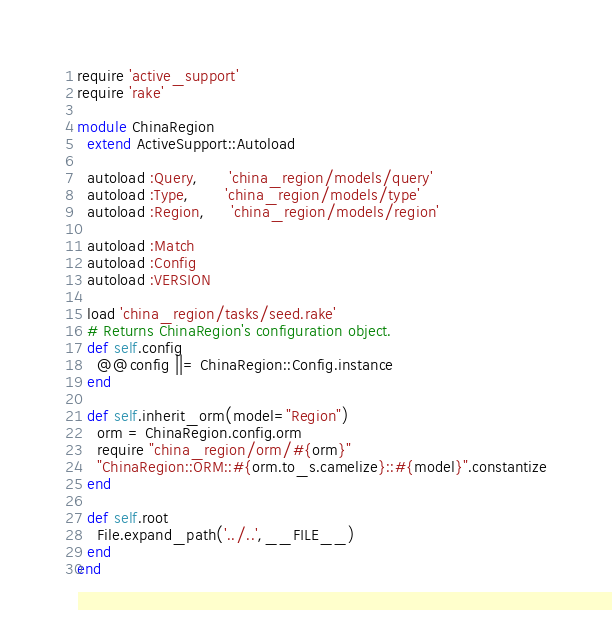<code> <loc_0><loc_0><loc_500><loc_500><_Ruby_>require 'active_support'
require 'rake'

module ChinaRegion
  extend ActiveSupport::Autoload

  autoload :Query,      'china_region/models/query'
  autoload :Type,       'china_region/models/type'
  autoload :Region,     'china_region/models/region'

  autoload :Match
  autoload :Config
  autoload :VERSION

  load 'china_region/tasks/seed.rake'
  # Returns ChinaRegion's configuration object.
  def self.config
    @@config ||= ChinaRegion::Config.instance
  end

  def self.inherit_orm(model="Region")
    orm = ChinaRegion.config.orm
    require "china_region/orm/#{orm}"
    "ChinaRegion::ORM::#{orm.to_s.camelize}::#{model}".constantize
  end

  def self.root
    File.expand_path('../..',__FILE__)
  end
end
</code> 